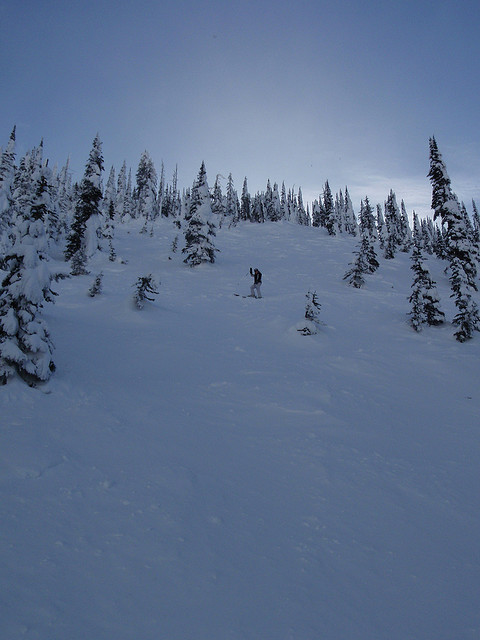What kind of trees can be seen in the image? The snow-laden scene is beautifully punctuated by towering pine and fir trees, their branches heavy with snow. These trees not only provide a scenic backdrop but also play a crucial role in stabilizing the snowpack and sheltering the wildlife native to this wintry habitat. 